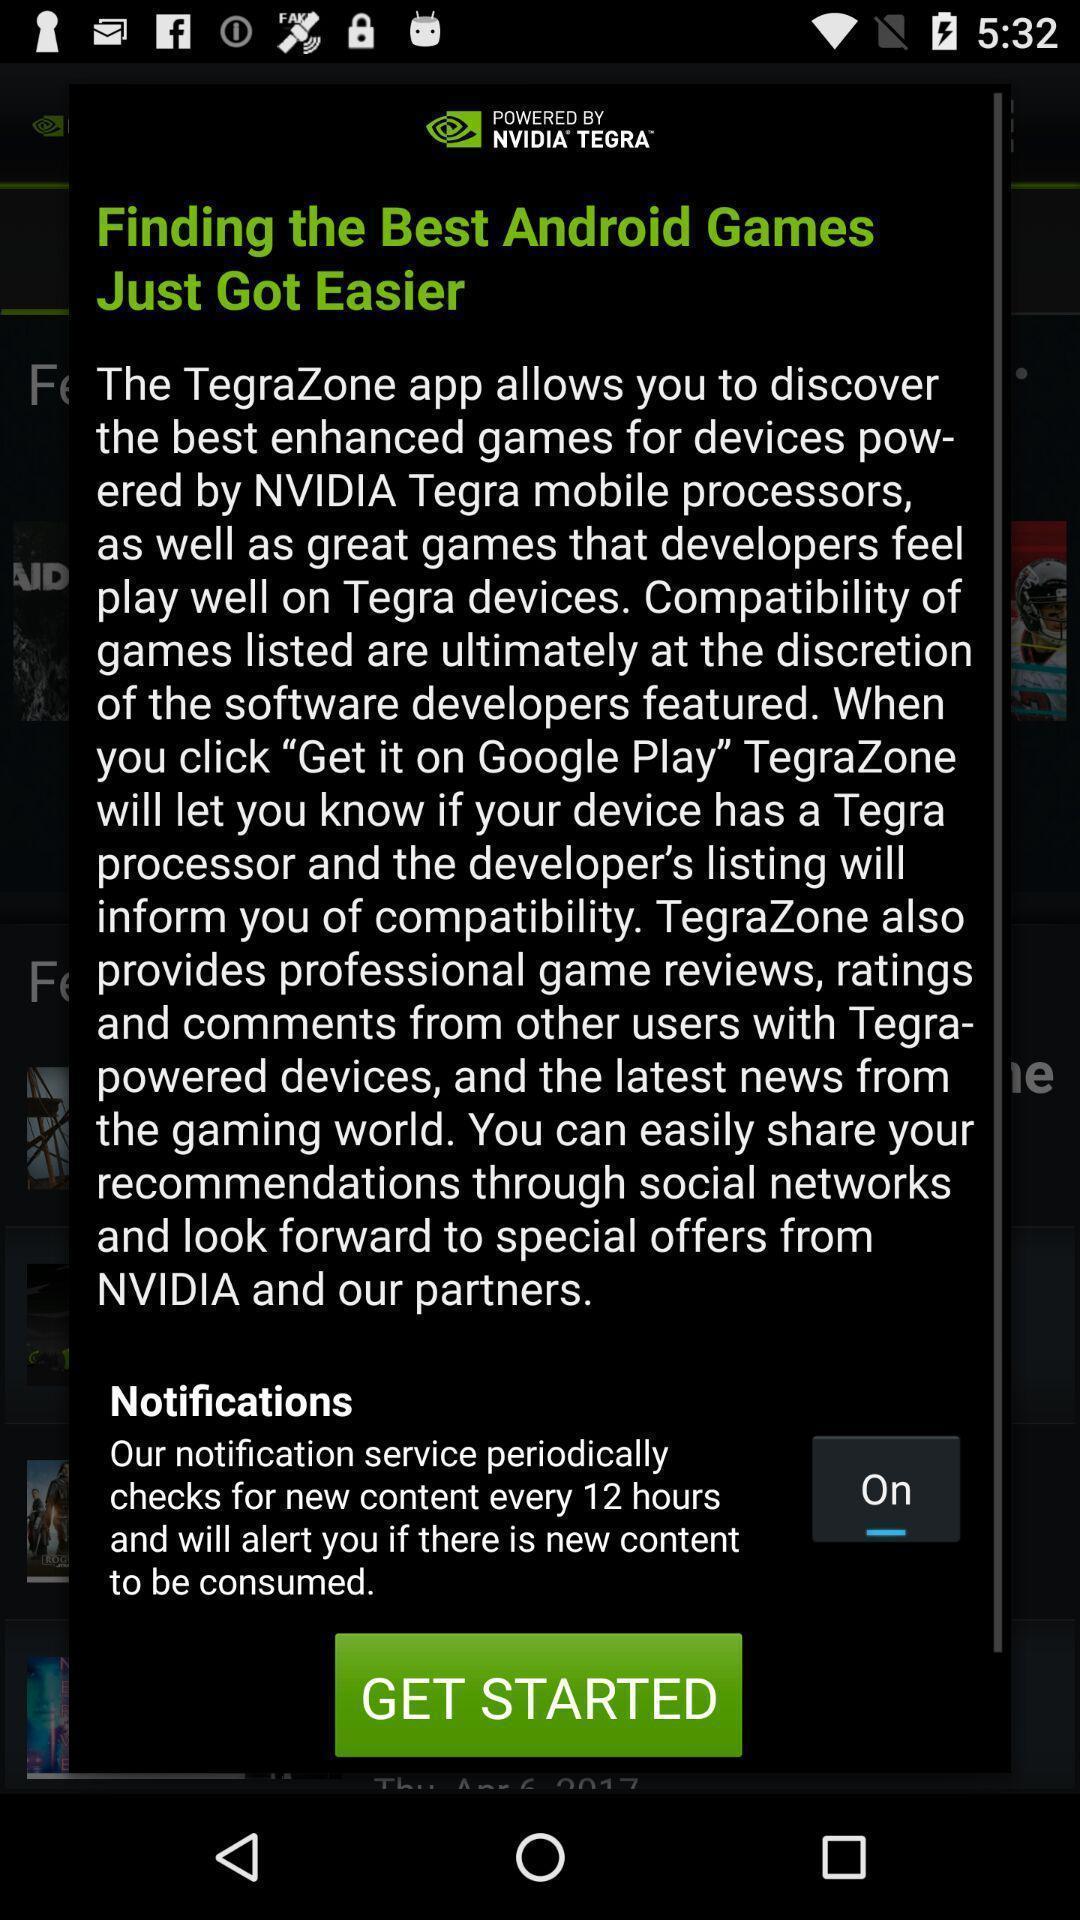Give me a narrative description of this picture. Push up displaying about games. 